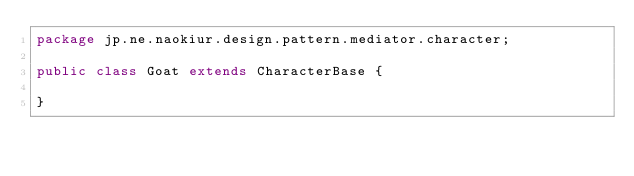Convert code to text. <code><loc_0><loc_0><loc_500><loc_500><_Java_>package jp.ne.naokiur.design.pattern.mediator.character;

public class Goat extends CharacterBase {

}
</code> 